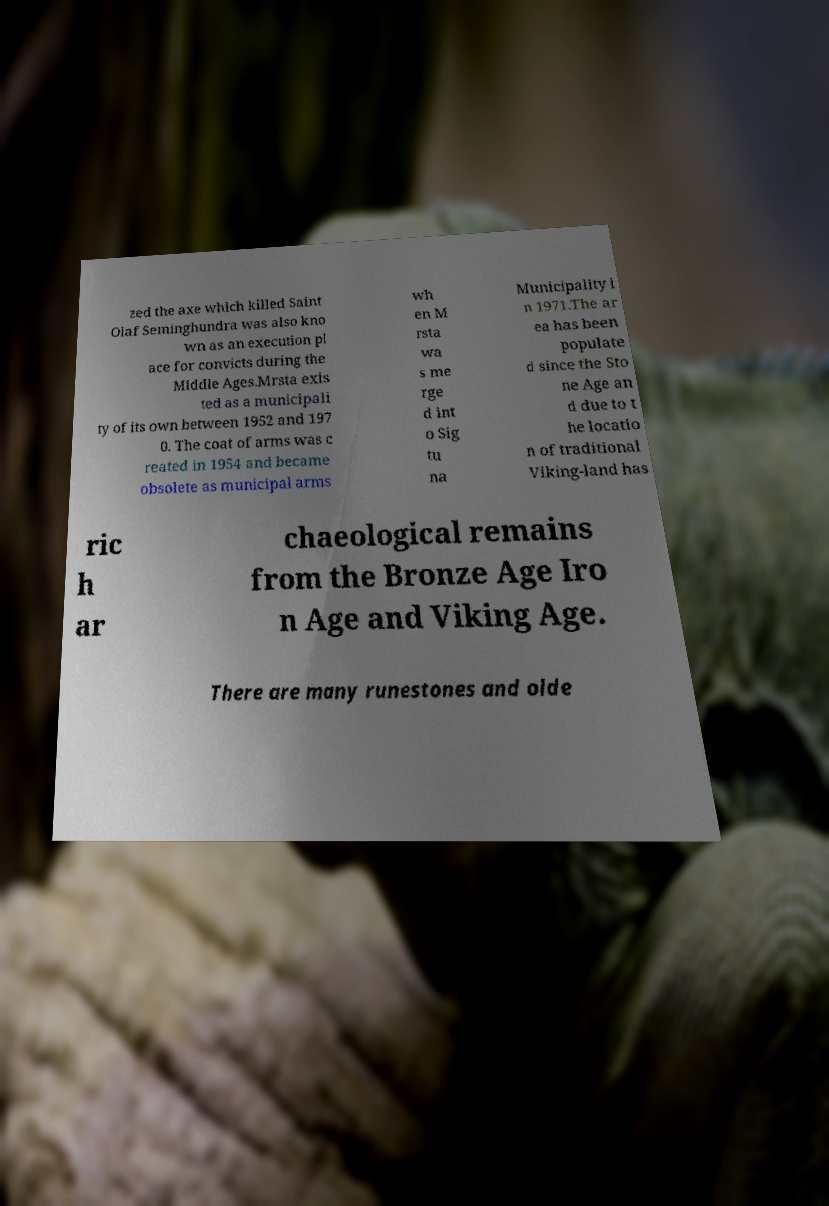Could you assist in decoding the text presented in this image and type it out clearly? zed the axe which killed Saint Olaf Seminghundra was also kno wn as an execution pl ace for convicts during the Middle Ages.Mrsta exis ted as a municipali ty of its own between 1952 and 197 0. The coat of arms was c reated in 1954 and became obsolete as municipal arms wh en M rsta wa s me rge d int o Sig tu na Municipality i n 1971.The ar ea has been populate d since the Sto ne Age an d due to t he locatio n of traditional Viking-land has ric h ar chaeological remains from the Bronze Age Iro n Age and Viking Age. There are many runestones and olde 